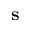Convert formula to latex. <formula><loc_0><loc_0><loc_500><loc_500>s</formula> 